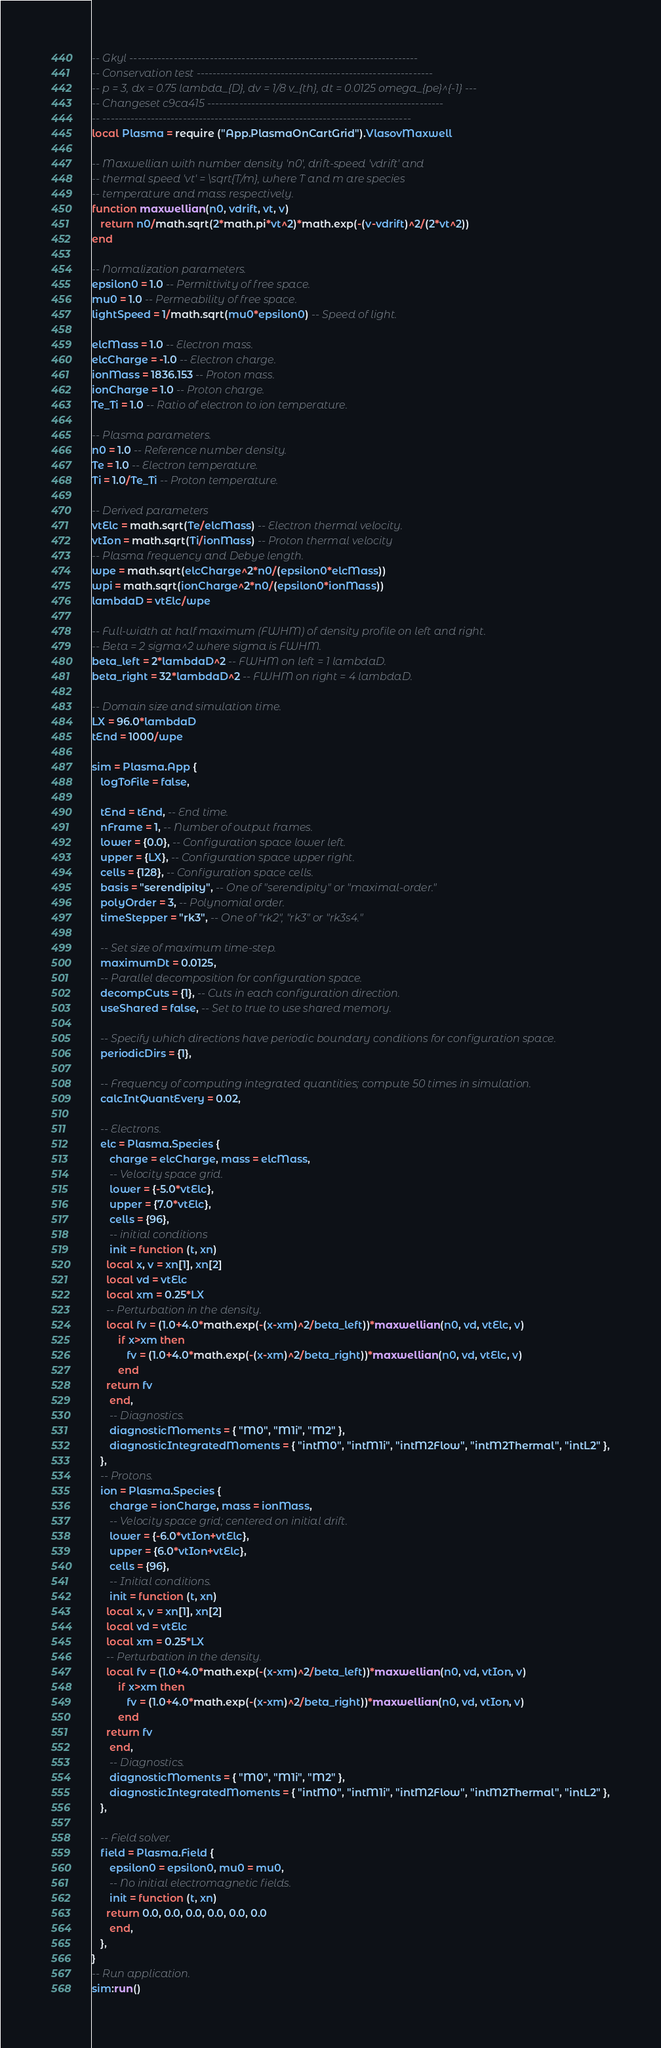<code> <loc_0><loc_0><loc_500><loc_500><_Lua_>-- Gkyl ------------------------------------------------------------------------
-- Conservation test -----------------------------------------------------------
-- p = 3, dx = 0.75 lambda_{D}, dv = 1/8 v_{th}, dt = 0.0125 omega_{pe}^{-1} ---
-- Changeset c9ca415 -----------------------------------------------------------
-- -----------------------------------------------------------------------------
local Plasma = require ("App.PlasmaOnCartGrid").VlasovMaxwell

-- Maxwellian with number density 'n0', drift-speed 'vdrift' and
-- thermal speed 'vt' = \sqrt{T/m}, where T and m are species
-- temperature and mass respectively.
function maxwellian(n0, vdrift, vt, v)
   return n0/math.sqrt(2*math.pi*vt^2)*math.exp(-(v-vdrift)^2/(2*vt^2))
end

-- Normalization parameters.
epsilon0 = 1.0 -- Permittivity of free space.
mu0 = 1.0 -- Permeability of free space.
lightSpeed = 1/math.sqrt(mu0*epsilon0) -- Speed of light.

elcMass = 1.0 -- Electron mass.
elcCharge = -1.0 -- Electron charge.
ionMass = 1836.153 -- Proton mass.
ionCharge = 1.0 -- Proton charge.
Te_Ti = 1.0 -- Ratio of electron to ion temperature.

-- Plasma parameters.
n0 = 1.0 -- Reference number density.
Te = 1.0 -- Electron temperature.
Ti = 1.0/Te_Ti -- Proton temperature.

-- Derived parameters
vtElc = math.sqrt(Te/elcMass) -- Electron thermal velocity.
vtIon = math.sqrt(Ti/ionMass) -- Proton thermal velocity
-- Plasma frequency and Debye length.
wpe = math.sqrt(elcCharge^2*n0/(epsilon0*elcMass))
wpi = math.sqrt(ionCharge^2*n0/(epsilon0*ionMass))
lambdaD = vtElc/wpe

-- Full-width at half maximum (FWHM) of density profile on left and right.
-- Beta = 2 sigma^2 where sigma is FWHM.
beta_left = 2*lambdaD^2 -- FWHM on left = 1 lambdaD.
beta_right = 32*lambdaD^2 -- FWHM on right = 4 lambdaD.

-- Domain size and simulation time.
LX = 96.0*lambdaD
tEnd = 1000/wpe

sim = Plasma.App {
   logToFile = false,

   tEnd = tEnd, -- End time.
   nFrame = 1, -- Number of output frames.
   lower = {0.0}, -- Configuration space lower left.
   upper = {LX}, -- Configuration space upper right.
   cells = {128}, -- Configuration space cells.
   basis = "serendipity", -- One of "serendipity" or "maximal-order."
   polyOrder = 3, -- Polynomial order.
   timeStepper = "rk3", -- One of "rk2", "rk3" or "rk3s4."

   -- Set size of maximum time-step.
   maximumDt = 0.0125,
   -- Parallel decomposition for configuration space.
   decompCuts = {1}, -- Cuts in each configuration direction.
   useShared = false, -- Set to true to use shared memory.

   -- Specify which directions have periodic boundary conditions for configuration space.
   periodicDirs = {1},

   -- Frequency of computing integrated quantities; compute 50 times in simulation.
   calcIntQuantEvery = 0.02,

   -- Electrons.
   elc = Plasma.Species {
      charge = elcCharge, mass = elcMass,
      -- Velocity space grid.
      lower = {-5.0*vtElc},
      upper = {7.0*vtElc},
      cells = {96},
      -- initial conditions
      init = function (t, xn)
	 local x, v = xn[1], xn[2]
	 local vd = vtElc
	 local xm = 0.25*LX
	 -- Perturbation in the density.
	 local fv = (1.0+4.0*math.exp(-(x-xm)^2/beta_left))*maxwellian(n0, vd, vtElc, v) 
         if x>xm then
            fv = (1.0+4.0*math.exp(-(x-xm)^2/beta_right))*maxwellian(n0, vd, vtElc, v)
         end
	 return fv
      end,
      -- Diagnostics.
      diagnosticMoments = { "M0", "M1i", "M2" },
      diagnosticIntegratedMoments = { "intM0", "intM1i", "intM2Flow", "intM2Thermal", "intL2" },
   },
   -- Protons.
   ion = Plasma.Species {
      charge = ionCharge, mass = ionMass,
      -- Velocity space grid; centered on initial drift.
      lower = {-6.0*vtIon+vtElc},
      upper = {6.0*vtIon+vtElc},
      cells = {96},
      -- Initial conditions.
      init = function (t, xn)
	 local x, v = xn[1], xn[2]
	 local vd = vtElc
	 local xm = 0.25*LX
	 -- Perturbation in the density.
	 local fv = (1.0+4.0*math.exp(-(x-xm)^2/beta_left))*maxwellian(n0, vd, vtIon, v) 
         if x>xm then
            fv = (1.0+4.0*math.exp(-(x-xm)^2/beta_right))*maxwellian(n0, vd, vtIon, v)
         end
	 return fv
      end,
      -- Diagnostics.
      diagnosticMoments = { "M0", "M1i", "M2" },
      diagnosticIntegratedMoments = { "intM0", "intM1i", "intM2Flow", "intM2Thermal", "intL2" },
   },

   -- Field solver.
   field = Plasma.Field {
      epsilon0 = epsilon0, mu0 = mu0,
      -- No initial electromagnetic fields.
      init = function (t, xn)
	 return 0.0, 0.0, 0.0, 0.0, 0.0, 0.0
      end,
   },
}
-- Run application.
sim:run()
</code> 